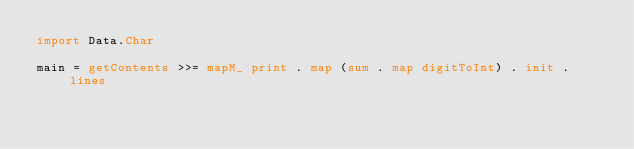<code> <loc_0><loc_0><loc_500><loc_500><_Haskell_>import Data.Char

main = getContents >>= mapM_ print . map (sum . map digitToInt) . init . lines</code> 